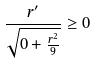Convert formula to latex. <formula><loc_0><loc_0><loc_500><loc_500>\frac { r ^ { \prime } } { \sqrt { 0 + \frac { r ^ { 2 } } { 9 } } } \geq 0</formula> 